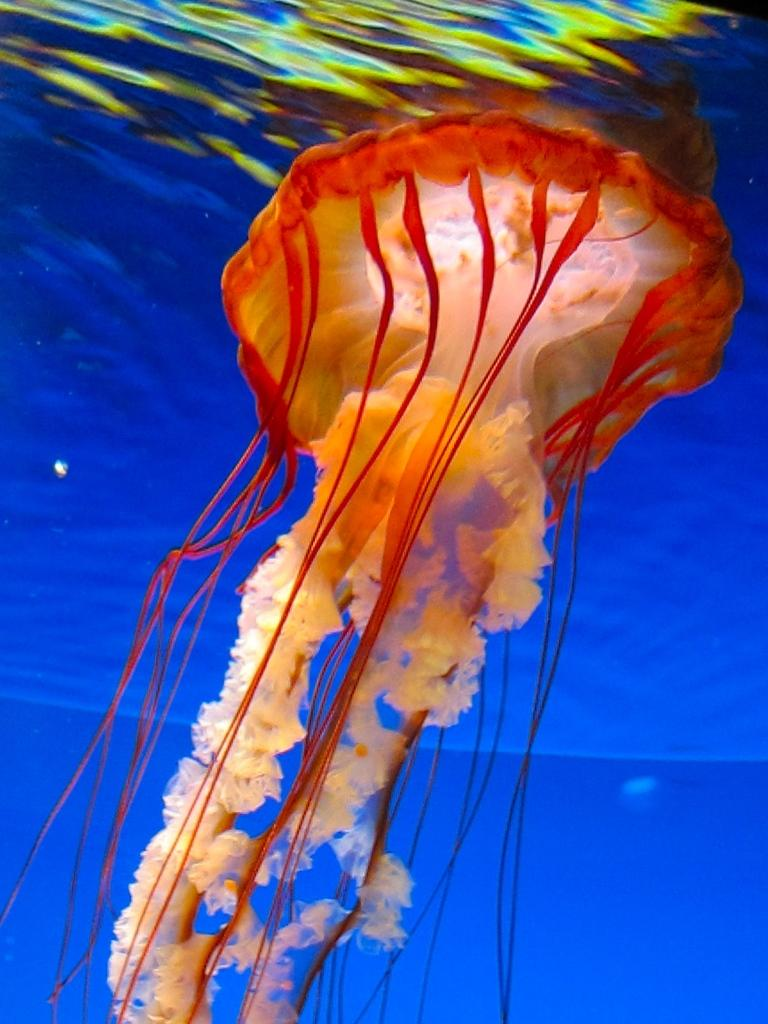What type of animal is in the image? There is a jellyfish in the image. Where is the jellyfish located? The jellyfish is in the water. What type of clock is visible in the image? There is no clock present in the image; it features a jellyfish in the water. What substance is the jellyfish made of in the image? The jellyfish is a living organism made of various tissues and materials, but it is not a substance in the traditional sense. 